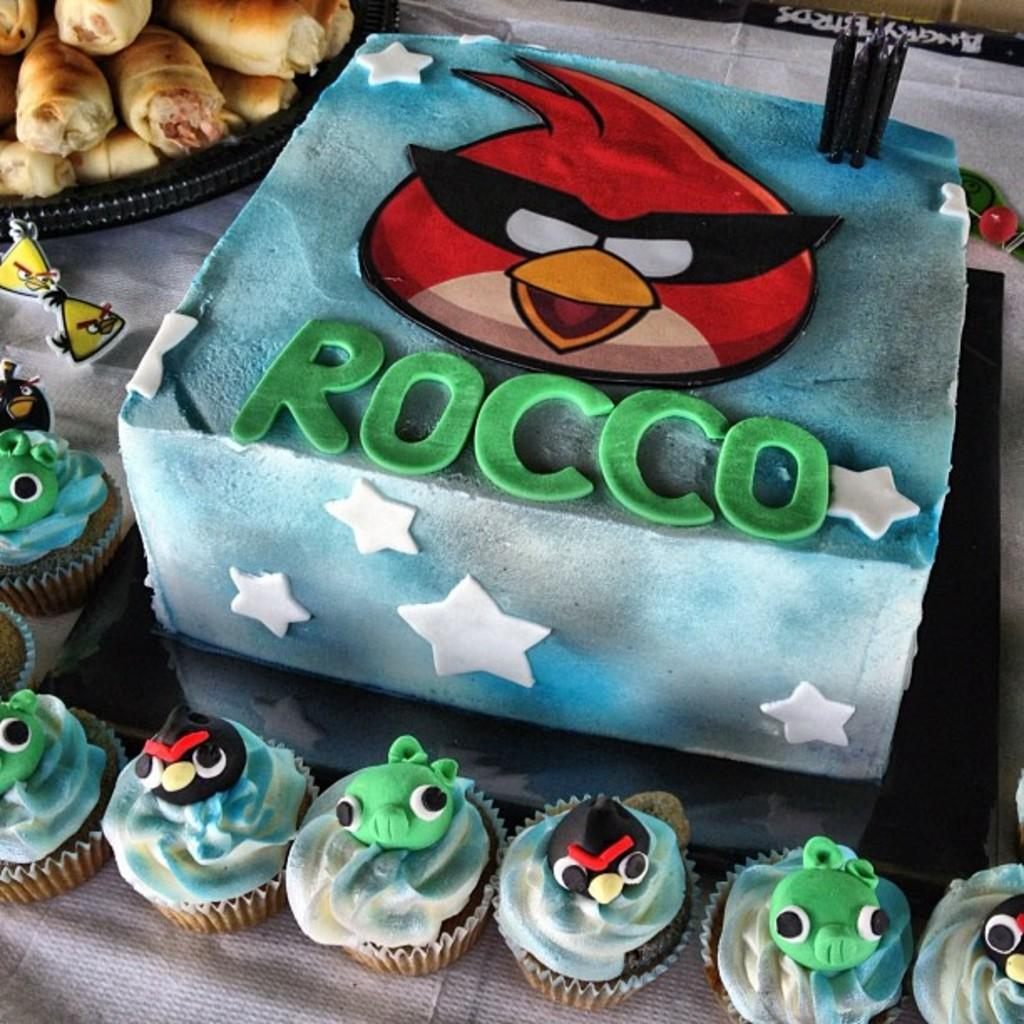What is the main piece of furniture in the image? There is a table in the image. What is placed on the table? There is a cake, cupcakes, and a bowl with a food item in it on the table. Can you describe the cake on the table? The cake is on the table, but the specific details of the cake cannot be determined from the provided facts. What is the texture of the silverware on the table? There is no silverware mentioned in the provided facts, so it cannot be determined if there is any on the table or what its texture might be. 